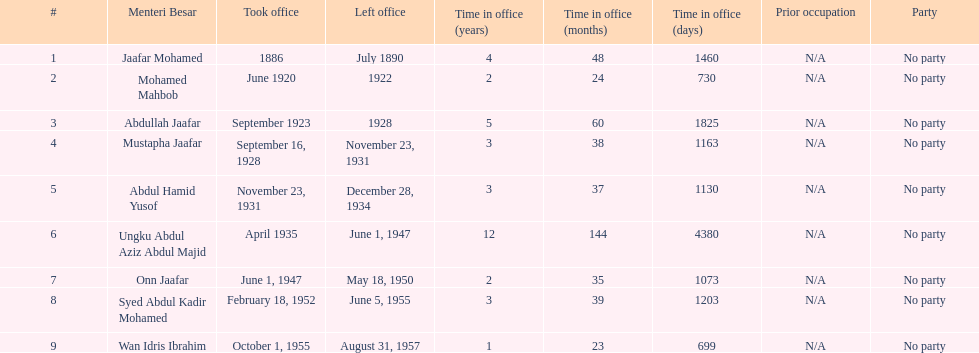Parse the full table. {'header': ['#', 'Menteri Besar', 'Took office', 'Left office', 'Time in office (years)', 'Time in office (months)', 'Time in office (days)', 'Prior occupation', 'Party'], 'rows': [['1', 'Jaafar Mohamed', '1886', 'July 1890', '4', '48', '1460', 'N/A', 'No party'], ['2', 'Mohamed Mahbob', 'June 1920', '1922', '2', '24', '730', 'N/A', 'No party'], ['3', 'Abdullah Jaafar', 'September 1923', '1928', '5', '60', '1825', 'N/A', 'No party'], ['4', 'Mustapha Jaafar', 'September 16, 1928', 'November 23, 1931', '3', '38', '1163', 'N/A', 'No party'], ['5', 'Abdul Hamid Yusof', 'November 23, 1931', 'December 28, 1934', '3', '37', '1130', 'N/A', 'No party'], ['6', 'Ungku Abdul Aziz Abdul Majid', 'April 1935', 'June 1, 1947', '12', '144', '4380', 'N/A', 'No party'], ['7', 'Onn Jaafar', 'June 1, 1947', 'May 18, 1950', '2', '35', '1073', 'N/A', 'No party'], ['8', 'Syed Abdul Kadir Mohamed', 'February 18, 1952', 'June 5, 1955', '3', '39', '1203', 'N/A', 'No party'], ['9', 'Wan Idris Ibrahim', 'October 1, 1955', 'August 31, 1957', '1', '23', '699', 'N/A', 'No party']]} Other than abullah jaafar, name someone with the same last name. Mustapha Jaafar. 